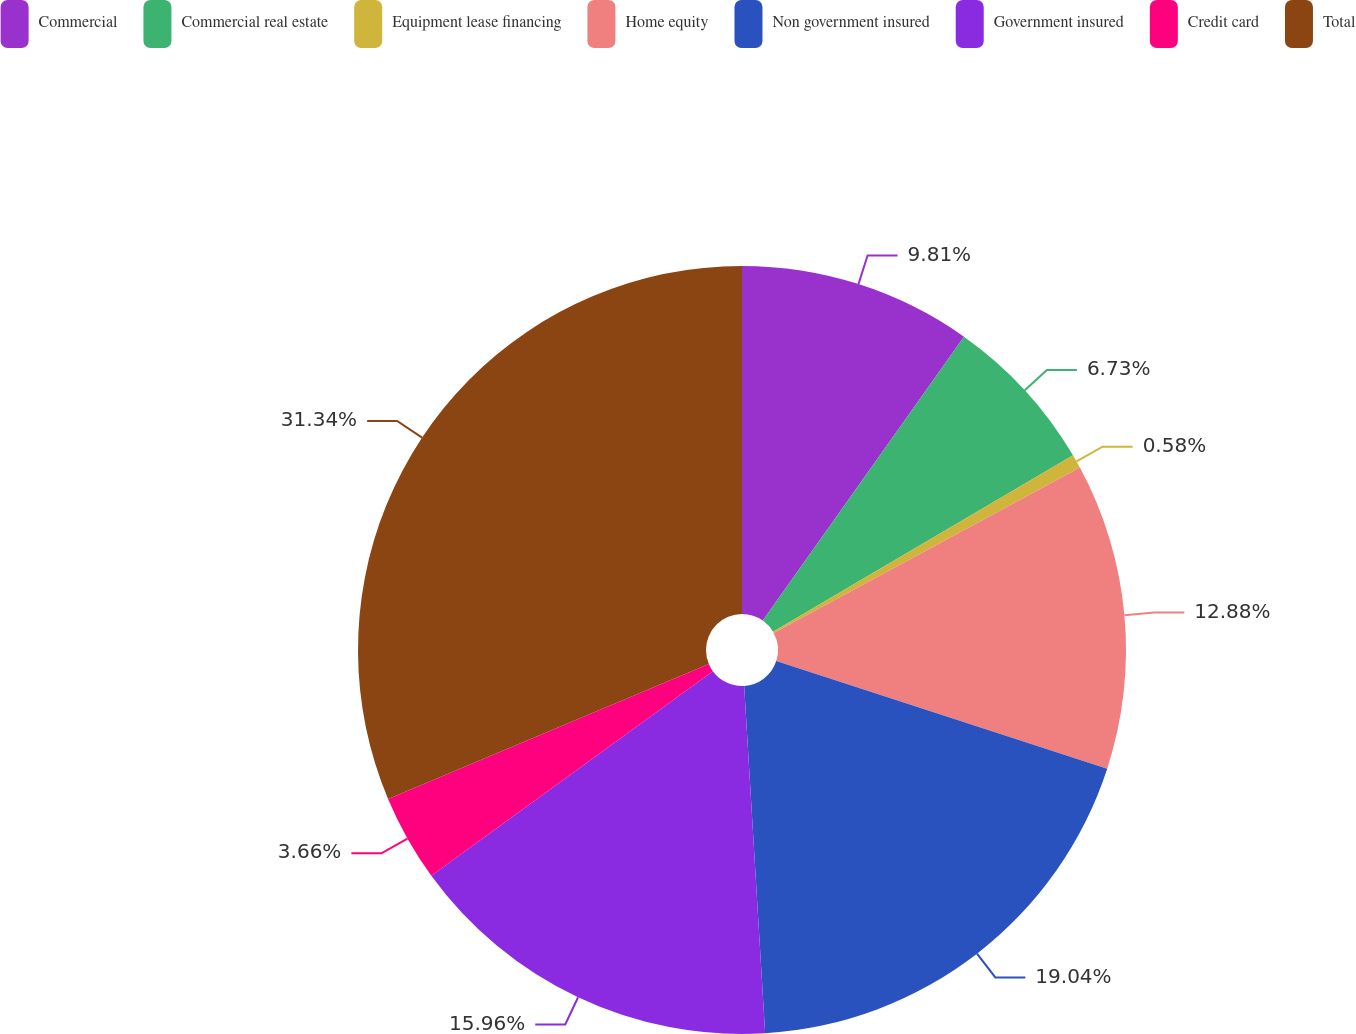Convert chart to OTSL. <chart><loc_0><loc_0><loc_500><loc_500><pie_chart><fcel>Commercial<fcel>Commercial real estate<fcel>Equipment lease financing<fcel>Home equity<fcel>Non government insured<fcel>Government insured<fcel>Credit card<fcel>Total<nl><fcel>9.81%<fcel>6.73%<fcel>0.58%<fcel>12.88%<fcel>19.04%<fcel>15.96%<fcel>3.66%<fcel>31.34%<nl></chart> 